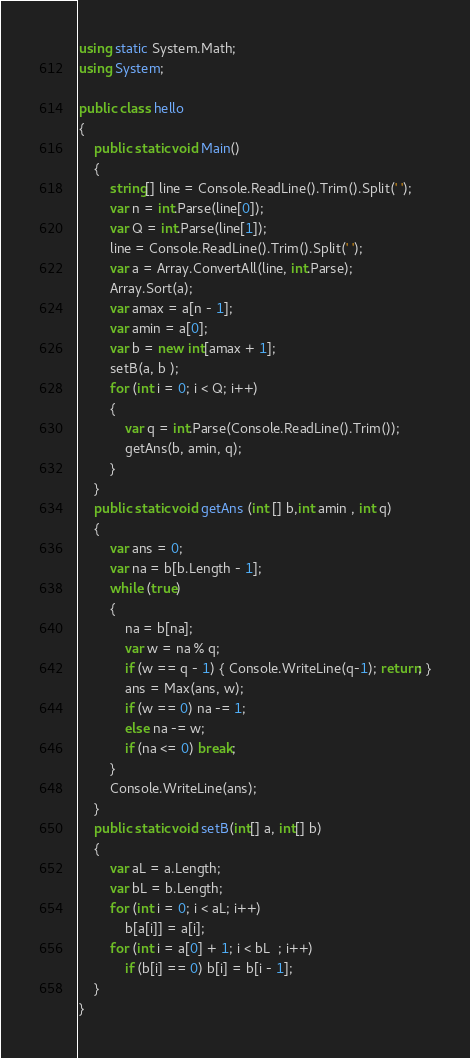<code> <loc_0><loc_0><loc_500><loc_500><_C#_>using static System.Math;
using System;

public class hello
{
    public static void Main()
    {
        string[] line = Console.ReadLine().Trim().Split(' ');
        var n = int.Parse(line[0]);
        var Q = int.Parse(line[1]);
        line = Console.ReadLine().Trim().Split(' ');
        var a = Array.ConvertAll(line, int.Parse);
        Array.Sort(a);
        var amax = a[n - 1];
        var amin = a[0];
        var b = new int[amax + 1];
        setB(a, b );
        for (int i = 0; i < Q; i++)
        {
            var q = int.Parse(Console.ReadLine().Trim());
            getAns(b, amin, q);
        }
    }
    public static void getAns (int [] b,int amin , int q)
    {
        var ans = 0;
        var na = b[b.Length - 1];
        while (true)
        {
            na = b[na];
            var w = na % q;
            if (w == q - 1) { Console.WriteLine(q-1); return; }
            ans = Max(ans, w);
            if (w == 0) na -= 1;
            else na -= w;
            if (na <= 0) break;
        }
        Console.WriteLine(ans);
    }
    public static void setB(int[] a, int[] b)
    {
        var aL = a.Length;
        var bL = b.Length;
        for (int i = 0; i < aL; i++)
            b[a[i]] = a[i];
        for (int i = a[0] + 1; i < bL  ; i++)
            if (b[i] == 0) b[i] = b[i - 1];
    }
}




</code> 